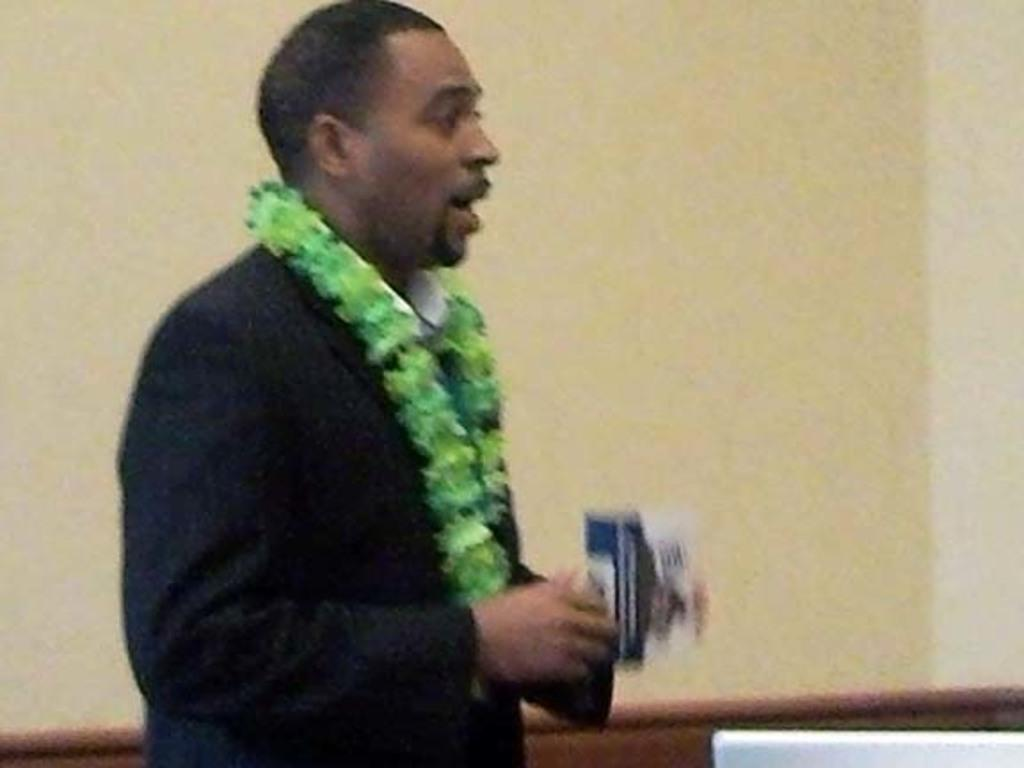What type of clothing is the person in the image wearing? The person in the image is wearing a suit. What additional accessory is the person wearing? The person is wearing a garland. What is the person holding in the image? The person is holding an object. What can be seen in the background of the image? There is a wall in the background of the image. What type of knee injury can be seen in the image? There is no knee injury present in the image. What type of boundary is visible in the image? There is no boundary visible in the image. 